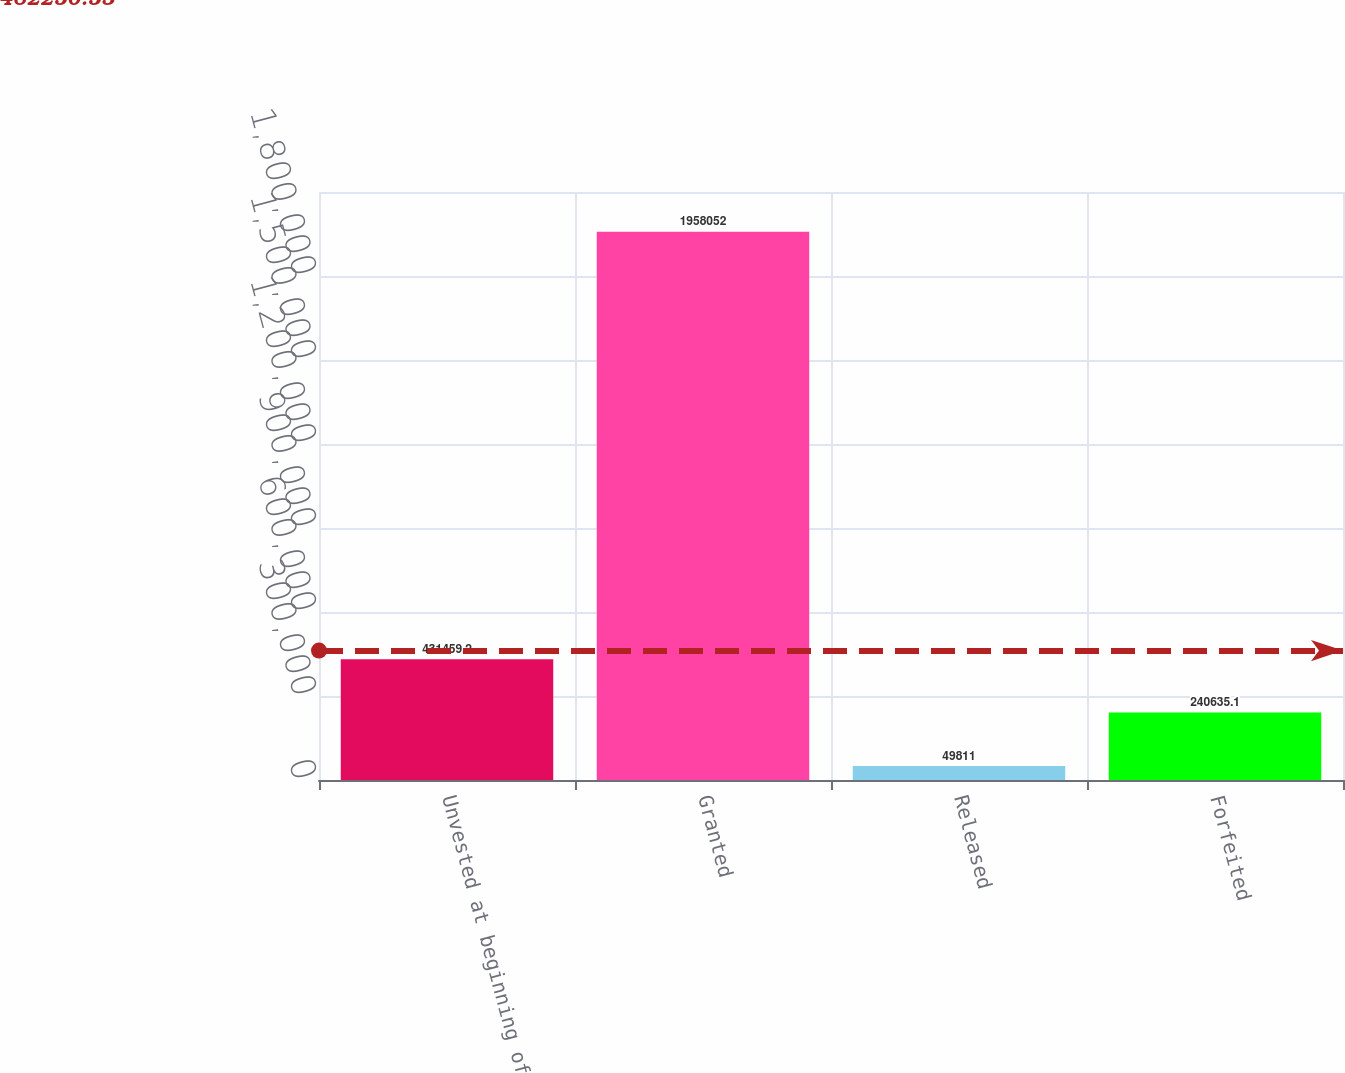Convert chart to OTSL. <chart><loc_0><loc_0><loc_500><loc_500><bar_chart><fcel>Unvested at beginning of<fcel>Granted<fcel>Released<fcel>Forfeited<nl><fcel>431459<fcel>1.95805e+06<fcel>49811<fcel>240635<nl></chart> 